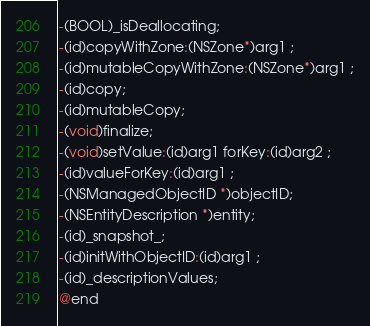Convert code to text. <code><loc_0><loc_0><loc_500><loc_500><_C_>-(BOOL)_isDeallocating;
-(id)copyWithZone:(NSZone*)arg1 ;
-(id)mutableCopyWithZone:(NSZone*)arg1 ;
-(id)copy;
-(id)mutableCopy;
-(void)finalize;
-(void)setValue:(id)arg1 forKey:(id)arg2 ;
-(id)valueForKey:(id)arg1 ;
-(NSManagedObjectID *)objectID;
-(NSEntityDescription *)entity;
-(id)_snapshot_;
-(id)initWithObjectID:(id)arg1 ;
-(id)_descriptionValues;
@end

</code> 